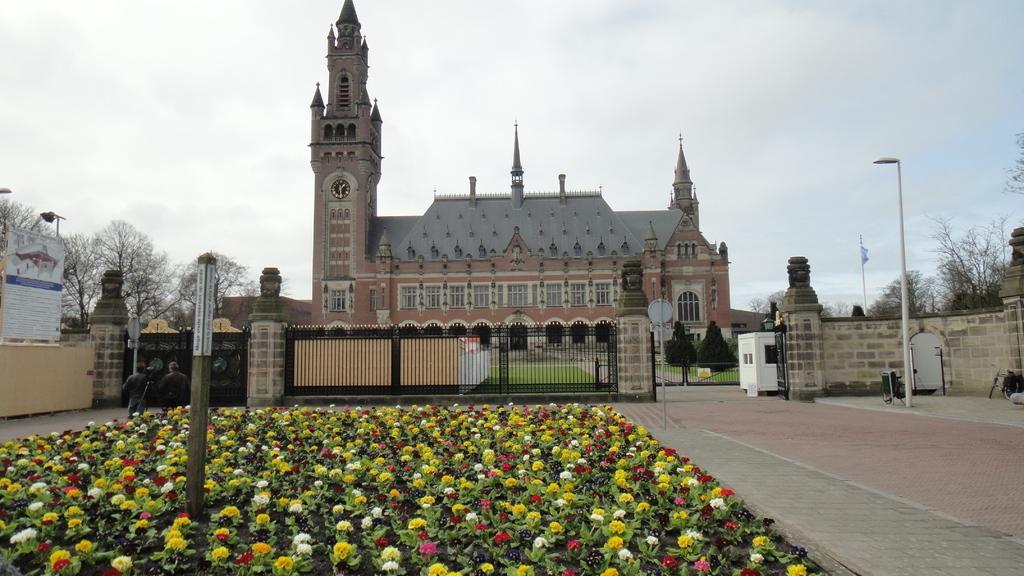In one or two sentences, can you explain what this image depicts? In this picture we can see a few flowers. There is some fencing. We can see a few trees, street lights and a flag on the right side. A building and a clock on this building. 